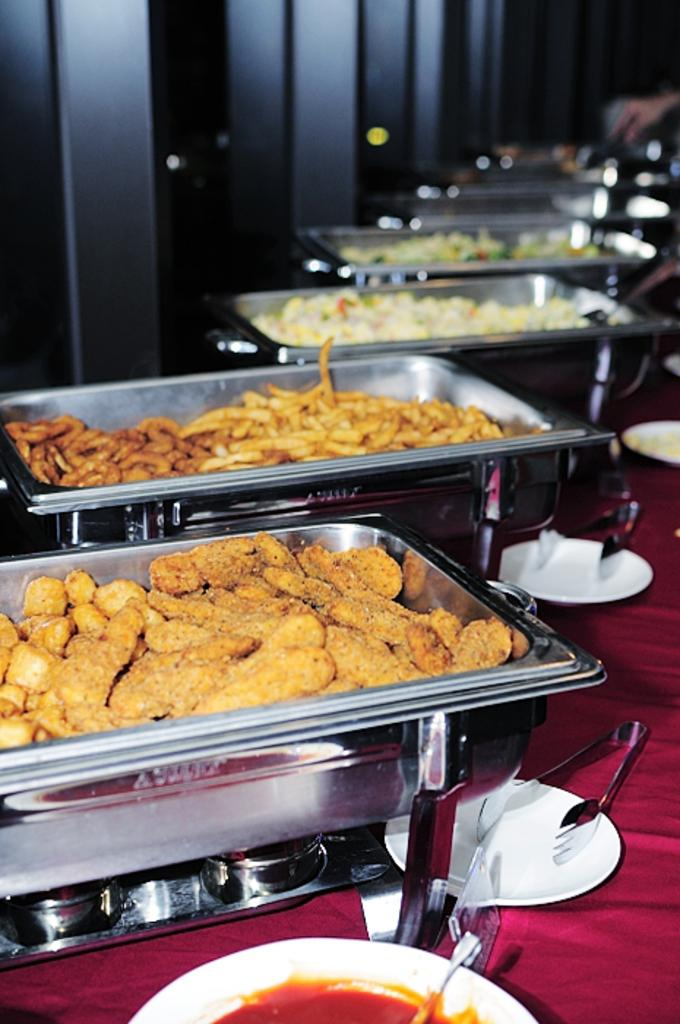What type of utensils can be seen in the image? There are spoons in the image. What is used for holding food in the image? There are plates and a bowl in the image. What are the food items stored in? The food items are in containers in the image. What is the color of the cloth beneath the items? The cloth beneath the items is red in color. What can be seen in the background of the image? There is a wall visible in the image. Is there any indication of a person's presence in the image? Yes, a hand of a person is present in the image. What type of ticket is being handed to the spy in the image? There is no ticket or spy present in the image. What is the chance of winning the game depicted in the image? There is no game or indication of winning in the image. 